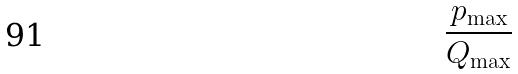Convert formula to latex. <formula><loc_0><loc_0><loc_500><loc_500>\frac { p _ { \max } } { Q _ { \max } }</formula> 